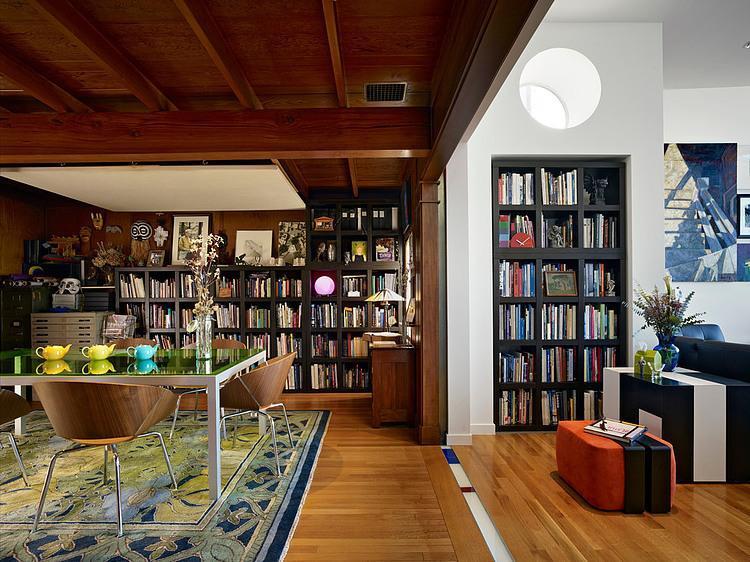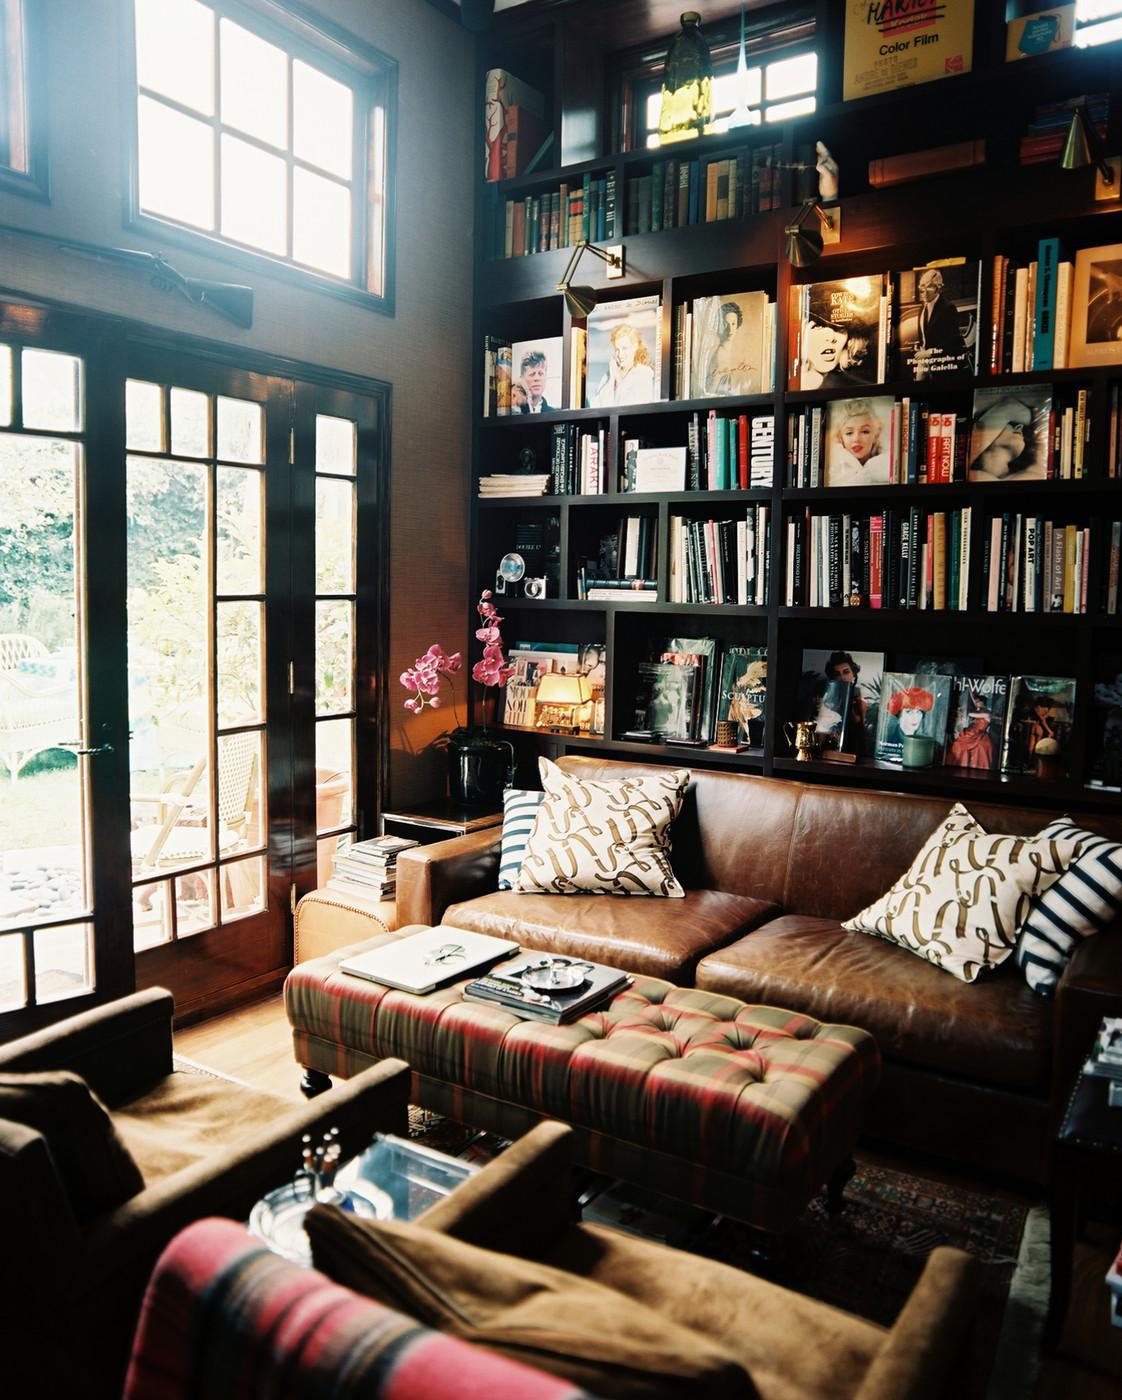The first image is the image on the left, the second image is the image on the right. For the images displayed, is the sentence "There are chairs with white seats." factually correct? Answer yes or no. No. The first image is the image on the left, the second image is the image on the right. Analyze the images presented: Is the assertion "In one image, a round dining table with chairs and centerpiece is located near large bookshelves." valid? Answer yes or no. No. 